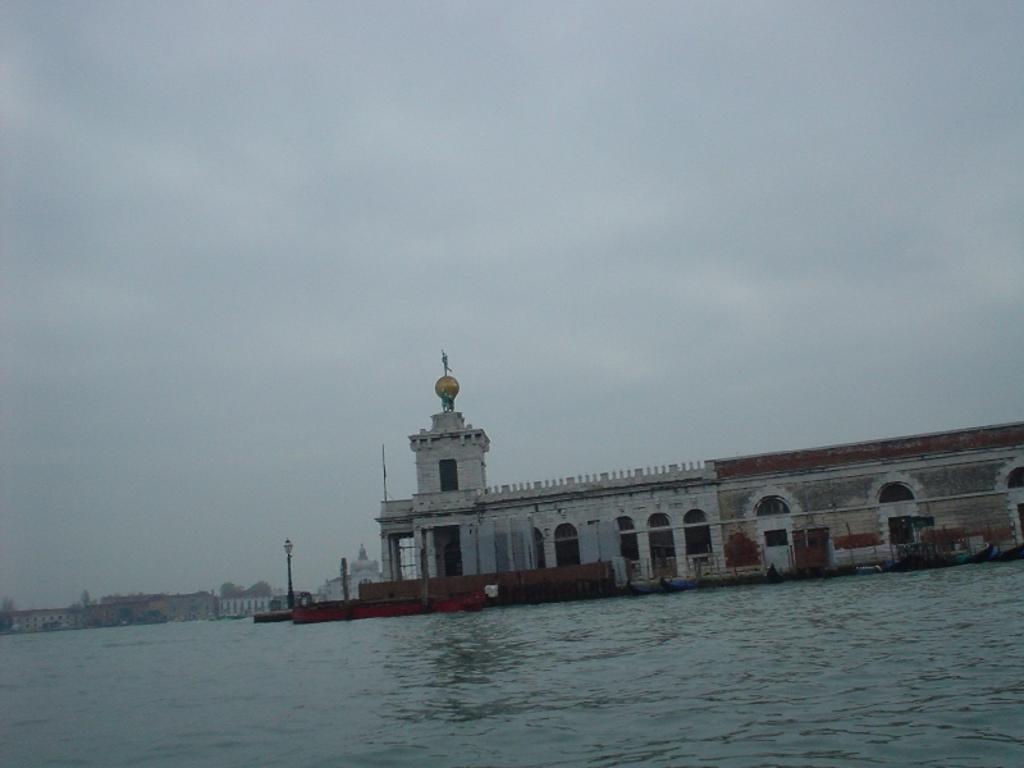Can you describe this image briefly? In this image we can see buildings, windows, light poles, trees, also we can the river, and the sky. 